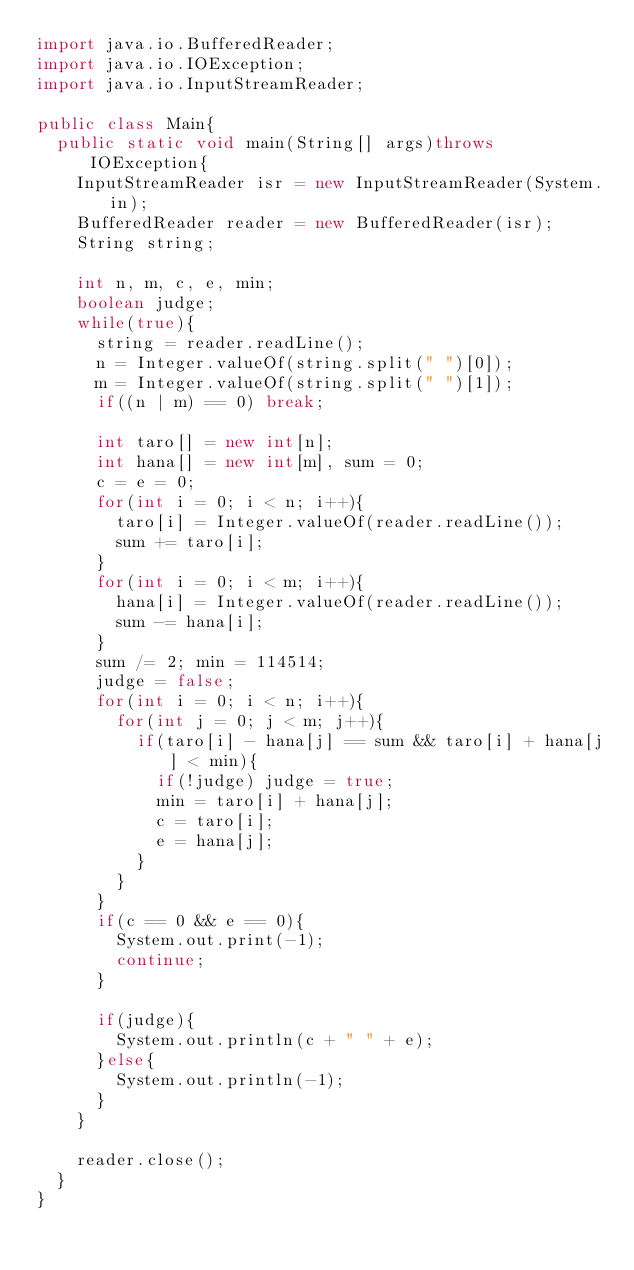Convert code to text. <code><loc_0><loc_0><loc_500><loc_500><_Java_>import java.io.BufferedReader;
import java.io.IOException;
import java.io.InputStreamReader;

public class Main{
	public static void main(String[] args)throws IOException{
		InputStreamReader isr = new InputStreamReader(System.in);
		BufferedReader reader = new BufferedReader(isr);
		String string;
		
		int n, m, c, e, min;
		boolean judge;
		while(true){
			string = reader.readLine();
			n = Integer.valueOf(string.split(" ")[0]);
			m = Integer.valueOf(string.split(" ")[1]);
			if((n | m) == 0) break;
			
			int taro[] = new int[n];
			int hana[] = new int[m], sum = 0;
			c = e = 0;
			for(int i = 0; i < n; i++){
				taro[i] = Integer.valueOf(reader.readLine());
				sum += taro[i];
			}
			for(int i = 0; i < m; i++){
				hana[i] = Integer.valueOf(reader.readLine());
				sum -= hana[i];
			}
			sum /= 2; min = 114514;
			judge = false;
			for(int i = 0; i < n; i++){
				for(int j = 0; j < m; j++){
					if(taro[i] - hana[j] == sum && taro[i] + hana[j] < min){
						if(!judge) judge = true;
						min = taro[i] + hana[j];
						c = taro[i];
						e = hana[j];
					}
				}
			}
			if(c == 0 && e == 0){
				System.out.print(-1);
				continue;
			}
			
			if(judge){
				System.out.println(c + " " + e);
			}else{
				System.out.println(-1);
			}
		}
		
		reader.close();
	}
}</code> 